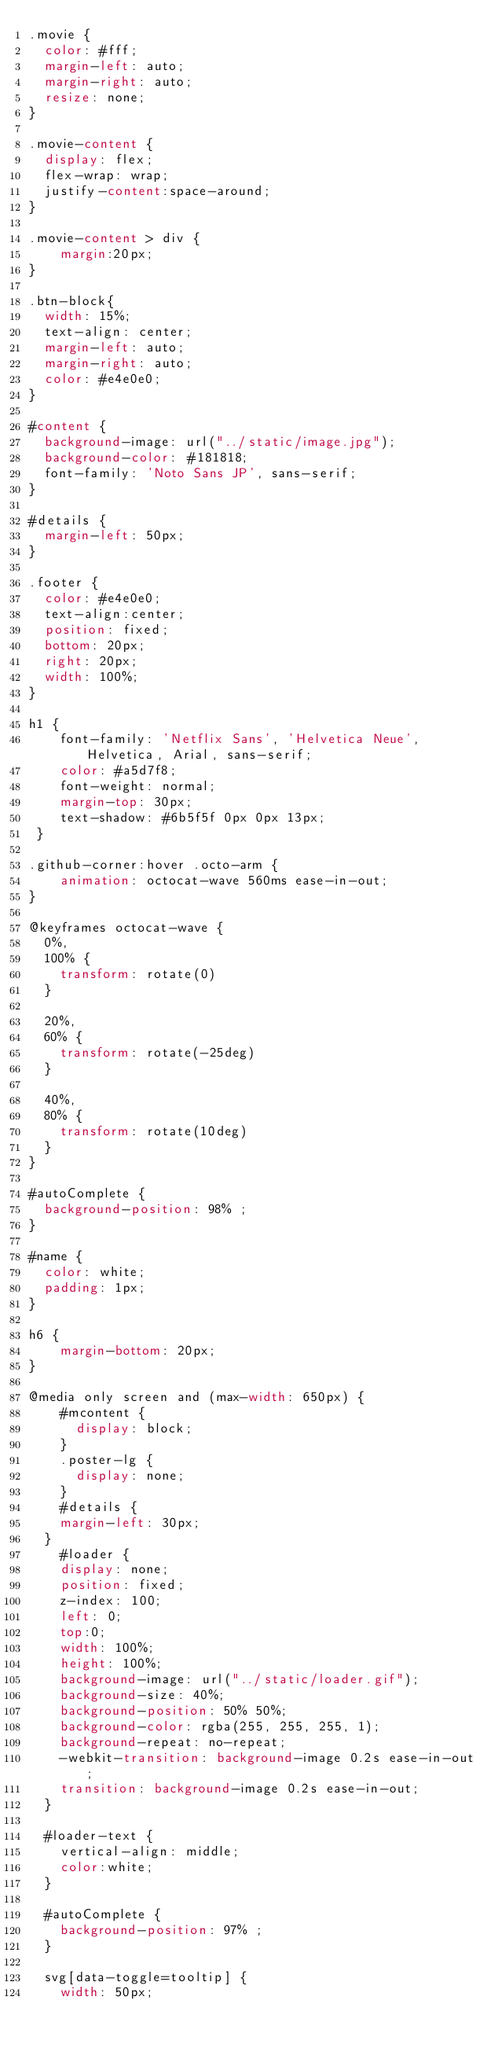<code> <loc_0><loc_0><loc_500><loc_500><_CSS_>.movie {
	color: #fff;
	margin-left: auto;
	margin-right: auto;
	resize: none;
}

.movie-content {
	display: flex;
	flex-wrap: wrap;
	justify-content:space-around;
}

.movie-content > div {
    margin:20px;
}

.btn-block{
	width: 15%;
	text-align: center;
	margin-left: auto;
	margin-right: auto;
	color: #e4e0e0;
}

#content {
	background-image: url("../static/image.jpg");
	background-color: #181818;
	font-family: 'Noto Sans JP', sans-serif;
}

#details {
	margin-left: 50px;
}

.footer {
	color: #e4e0e0;
	text-align:center;
	position: fixed;
 	bottom: 20px;
 	right: 20px;
 	width: 100%;
}

h1 {
    font-family: 'Netflix Sans', 'Helvetica Neue', Helvetica, Arial, sans-serif;
    color: #a5d7f8;
    font-weight: normal;
    margin-top: 30px;
    text-shadow: #6b5f5f 0px 0px 13px;
 }

.github-corner:hover .octo-arm {
  	animation: octocat-wave 560ms ease-in-out;
}

@keyframes octocat-wave {
  0%,
  100% {
    transform: rotate(0)
  }

  20%,
  60% {
    transform: rotate(-25deg)
  }

  40%,
  80% {
    transform: rotate(10deg)
  }
}

#autoComplete {
  background-position: 98% ;
}

#name {
	color: white;
	padding: 1px;
}

h6 {
    margin-bottom: 20px;  
}

@media only screen and (max-width: 650px) {
    #mcontent {
      display: block;
    }
    .poster-lg {
      display: none;
    }
    #details {
		margin-left: 30px;
	}
    #loader {
		display: none;
		position: fixed;
		z-index: 100;
		left: 0;
		top:0;
		width: 100%;
		height: 100%;
		background-image: url("../static/loader.gif");
		background-size: 40%;
		background-position: 50% 50%;
		background-color: rgba(255, 255, 255, 1);
		background-repeat: no-repeat;
		-webkit-transition: background-image 0.2s ease-in-out;
		transition: background-image 0.2s ease-in-out;
	}

	#loader-text {
		vertical-align: middle;
		color:white;
	}

	#autoComplete {
	  background-position: 97% ;
	}
	
	svg[data-toggle=tooltip] {
		width: 50px;</code> 